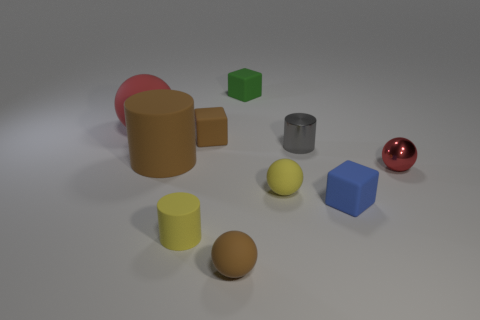Subtract all brown blocks. How many red balls are left? 2 Subtract 1 cylinders. How many cylinders are left? 2 Subtract all tiny cylinders. How many cylinders are left? 1 Subtract all cylinders. How many objects are left? 7 Subtract 1 red spheres. How many objects are left? 9 Subtract all blue spheres. Subtract all cyan cubes. How many spheres are left? 4 Subtract all small blue cubes. Subtract all big cylinders. How many objects are left? 8 Add 5 tiny rubber cylinders. How many tiny rubber cylinders are left? 6 Add 6 small blue blocks. How many small blue blocks exist? 7 